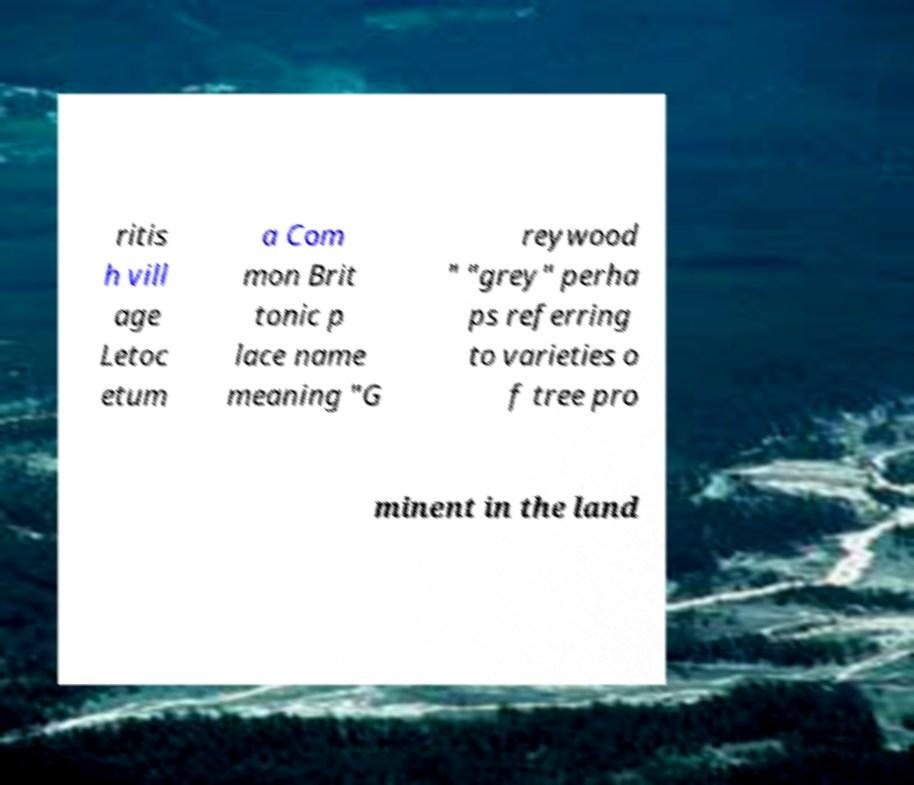For documentation purposes, I need the text within this image transcribed. Could you provide that? ritis h vill age Letoc etum a Com mon Brit tonic p lace name meaning "G reywood " "grey" perha ps referring to varieties o f tree pro minent in the land 